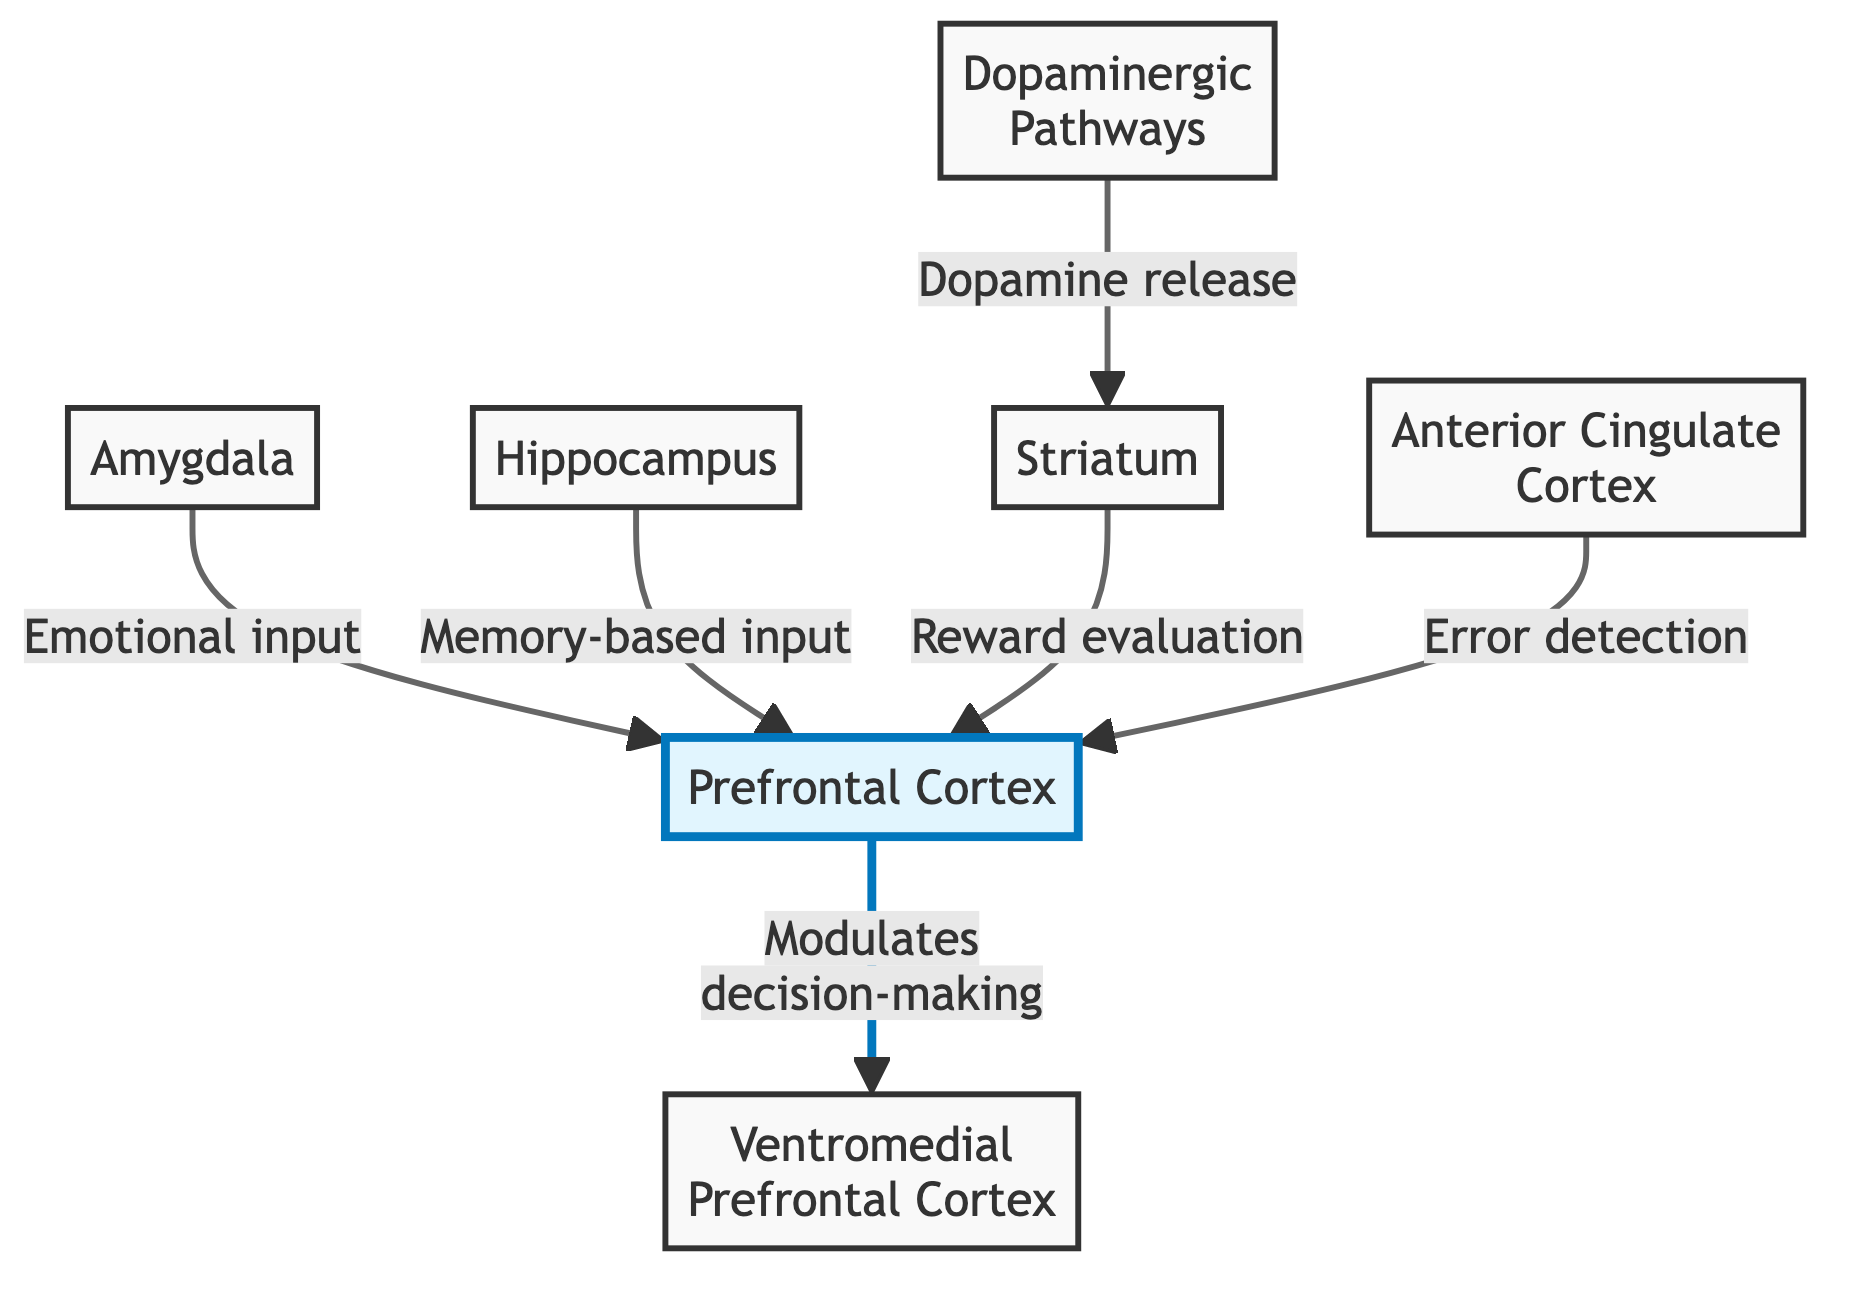What is the primary role of the Prefrontal Cortex? The diagram indicates that the Prefrontal Cortex modulates decision-making, shown by the direct arrow leading from PFC to VMPFC labeled "Modulates decision-making".
Answer: Modulates decision-making Which structure provides emotional input to the Prefrontal Cortex? The arrow from the Amygdala to the Prefrontal Cortex shows that the Amygdala is responsible for emotional input, as labeled in the diagram.
Answer: Amygdala How many primary structures are involved in the decision-making process according to the diagram? Counting the labeled structures in the diagram (PFC, VMPFC, AMY, HPC, STR, ACC, DOP), there are a total of 7 primary structures involved.
Answer: 7 What input does the Hippocampus provide to the Prefrontal Cortex? The diagram indicates that the Hippocampus provides memory-based input to the Prefrontal Cortex, represented by the arrow labeled "Memory-based input".
Answer: Memory-based input Which pathways are responsible for dopamine release? The diagram specifically labels the Dopaminergic pathways as responsible for dopamine release, indicated by the connection to the Striatum.
Answer: Dopaminergic pathways Which structure is the recipient of reward evaluation input? The diagram shows that the Striatum receives reward evaluation input, indicated by the arrow from the Striatum to the Prefrontal Cortex labeled as "Reward evaluation".
Answer: Striatum Describe the relationship between the Anterior Cingulate Cortex and the decision-making process. The arrow from the Anterior Cingulate Cortex to the Prefrontal Cortex specifies that the Anterior Cingulate Cortex is involved in error detection, which is a part of the decision-making process. This indicates its role in assessing decisions and outcomes.
Answer: Error detection What is the connection indicated by the arrow from the Dopaminergic pathways? The arrow labeled "Dopamine release" leading from the Dopaminergic pathways to the Striatum indicates that this connection relates to the release of dopamine, which affects decision-making in terms of reward perception.
Answer: Dopamine release What is the main output of the Striatum related to the Prefrontal Cortex? The diagram shows that the Striatum is responsible for reward evaluation, revealing that it processes outcomes related to reward before passing that information to the Prefrontal Cortex for decision-making.
Answer: Reward evaluation 